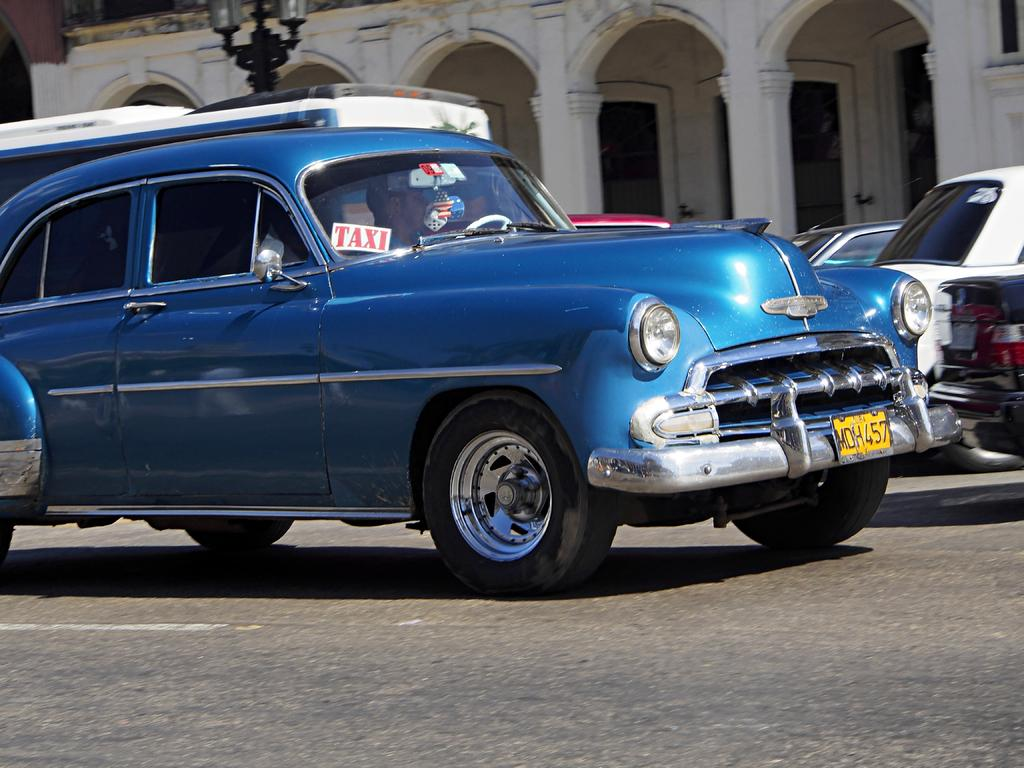What is located in the center of the image? There are vehicles on the road in the center of the image. What can be seen in the background of the image? There is a building, pillars, a pole, and other objects visible in the background of the image. How many vehicles are visible in the image? The number of vehicles is not specified, but there are vehicles on the road in the center of the image. What degree of difficulty does the frog face while crossing the road in the image? There is no frog present in the image, so it is not possible to determine the degree of difficulty it might face while crossing the road. 